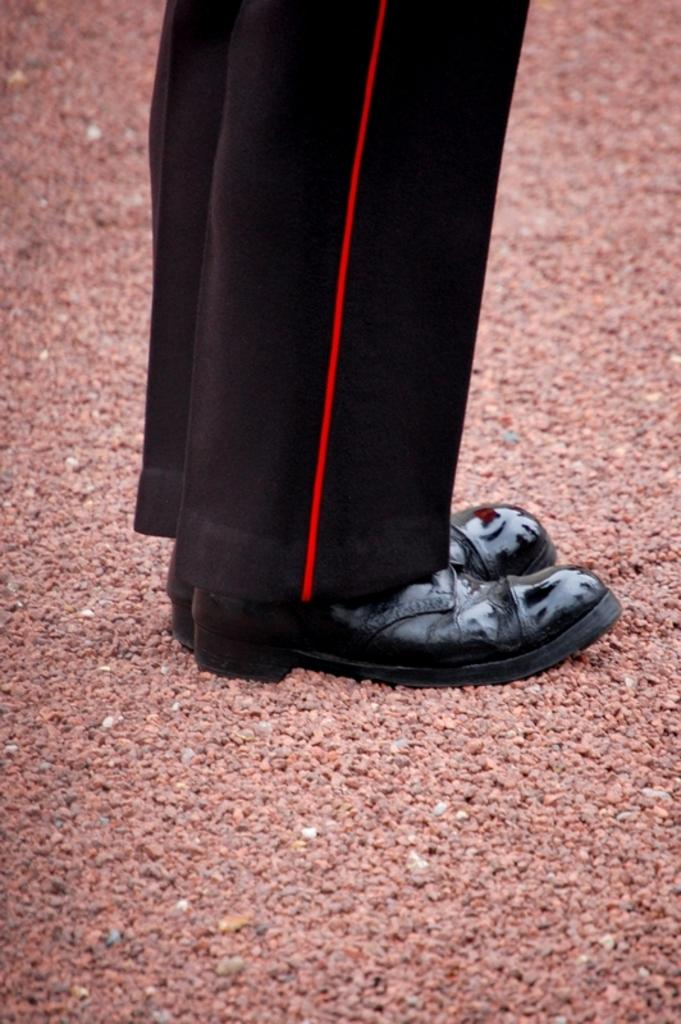What is the main subject of the image? There is a person in the image. What is the person wearing? The person is wearing a black dress and black shoes. What type of ground surface is visible in the image? There are pebbles visible in the image. What type of brass coil can be seen in the image? There is no brass coil present in the image. 